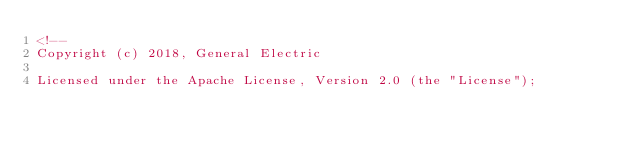Convert code to text. <code><loc_0><loc_0><loc_500><loc_500><_HTML_><!--
Copyright (c) 2018, General Electric

Licensed under the Apache License, Version 2.0 (the "License");</code> 